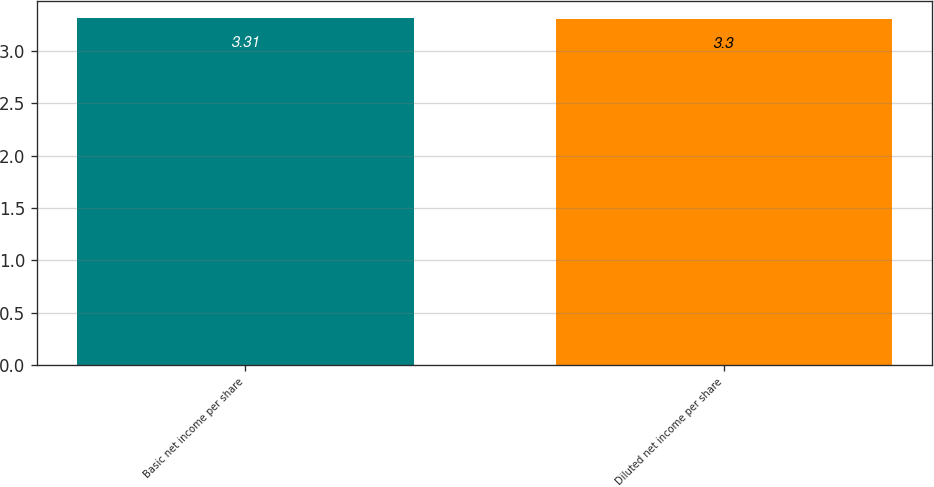Convert chart. <chart><loc_0><loc_0><loc_500><loc_500><bar_chart><fcel>Basic net income per share<fcel>Diluted net income per share<nl><fcel>3.31<fcel>3.3<nl></chart> 